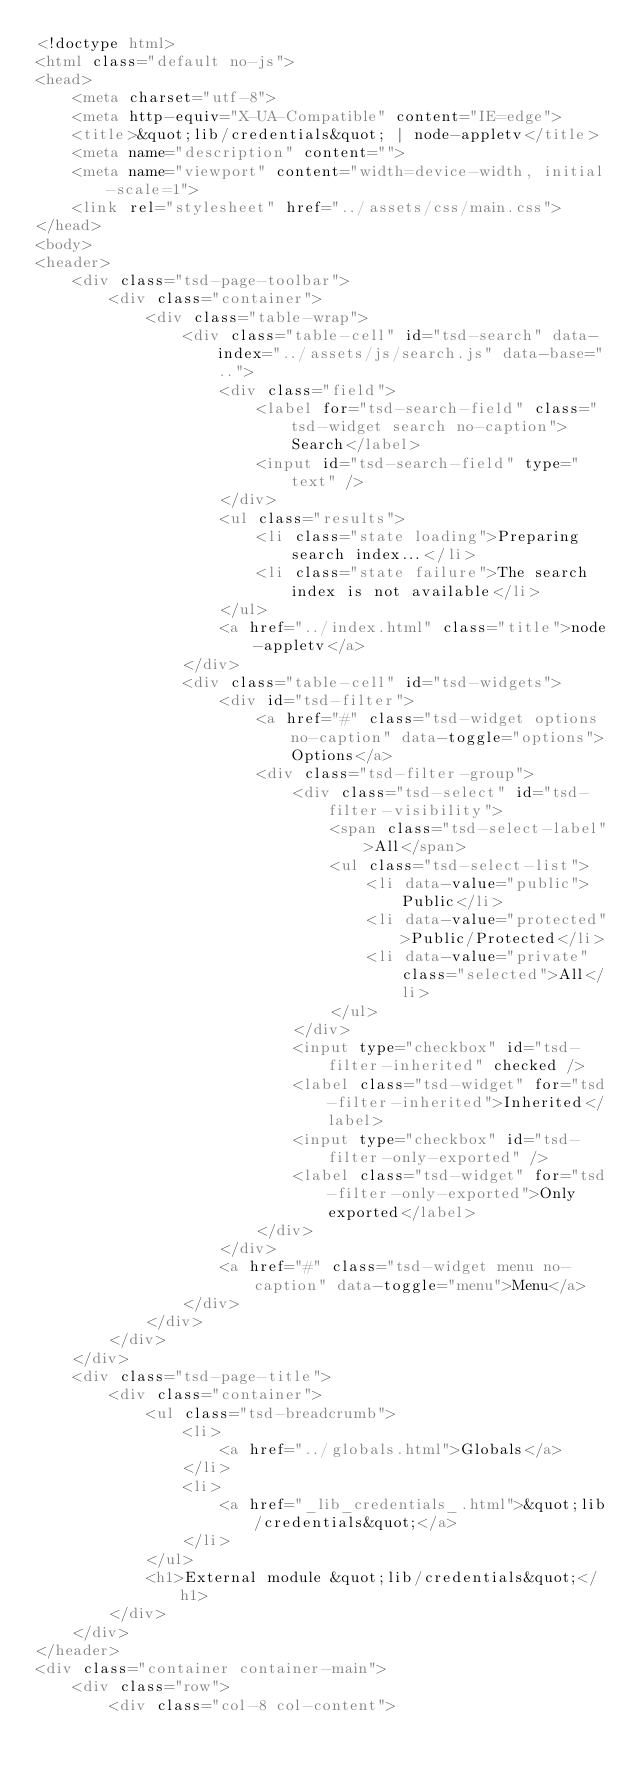<code> <loc_0><loc_0><loc_500><loc_500><_HTML_><!doctype html>
<html class="default no-js">
<head>
	<meta charset="utf-8">
	<meta http-equiv="X-UA-Compatible" content="IE=edge">
	<title>&quot;lib/credentials&quot; | node-appletv</title>
	<meta name="description" content="">
	<meta name="viewport" content="width=device-width, initial-scale=1">
	<link rel="stylesheet" href="../assets/css/main.css">
</head>
<body>
<header>
	<div class="tsd-page-toolbar">
		<div class="container">
			<div class="table-wrap">
				<div class="table-cell" id="tsd-search" data-index="../assets/js/search.js" data-base="..">
					<div class="field">
						<label for="tsd-search-field" class="tsd-widget search no-caption">Search</label>
						<input id="tsd-search-field" type="text" />
					</div>
					<ul class="results">
						<li class="state loading">Preparing search index...</li>
						<li class="state failure">The search index is not available</li>
					</ul>
					<a href="../index.html" class="title">node-appletv</a>
				</div>
				<div class="table-cell" id="tsd-widgets">
					<div id="tsd-filter">
						<a href="#" class="tsd-widget options no-caption" data-toggle="options">Options</a>
						<div class="tsd-filter-group">
							<div class="tsd-select" id="tsd-filter-visibility">
								<span class="tsd-select-label">All</span>
								<ul class="tsd-select-list">
									<li data-value="public">Public</li>
									<li data-value="protected">Public/Protected</li>
									<li data-value="private" class="selected">All</li>
								</ul>
							</div>
							<input type="checkbox" id="tsd-filter-inherited" checked />
							<label class="tsd-widget" for="tsd-filter-inherited">Inherited</label>
							<input type="checkbox" id="tsd-filter-only-exported" />
							<label class="tsd-widget" for="tsd-filter-only-exported">Only exported</label>
						</div>
					</div>
					<a href="#" class="tsd-widget menu no-caption" data-toggle="menu">Menu</a>
				</div>
			</div>
		</div>
	</div>
	<div class="tsd-page-title">
		<div class="container">
			<ul class="tsd-breadcrumb">
				<li>
					<a href="../globals.html">Globals</a>
				</li>
				<li>
					<a href="_lib_credentials_.html">&quot;lib/credentials&quot;</a>
				</li>
			</ul>
			<h1>External module &quot;lib/credentials&quot;</h1>
		</div>
	</div>
</header>
<div class="container container-main">
	<div class="row">
		<div class="col-8 col-content"></code> 